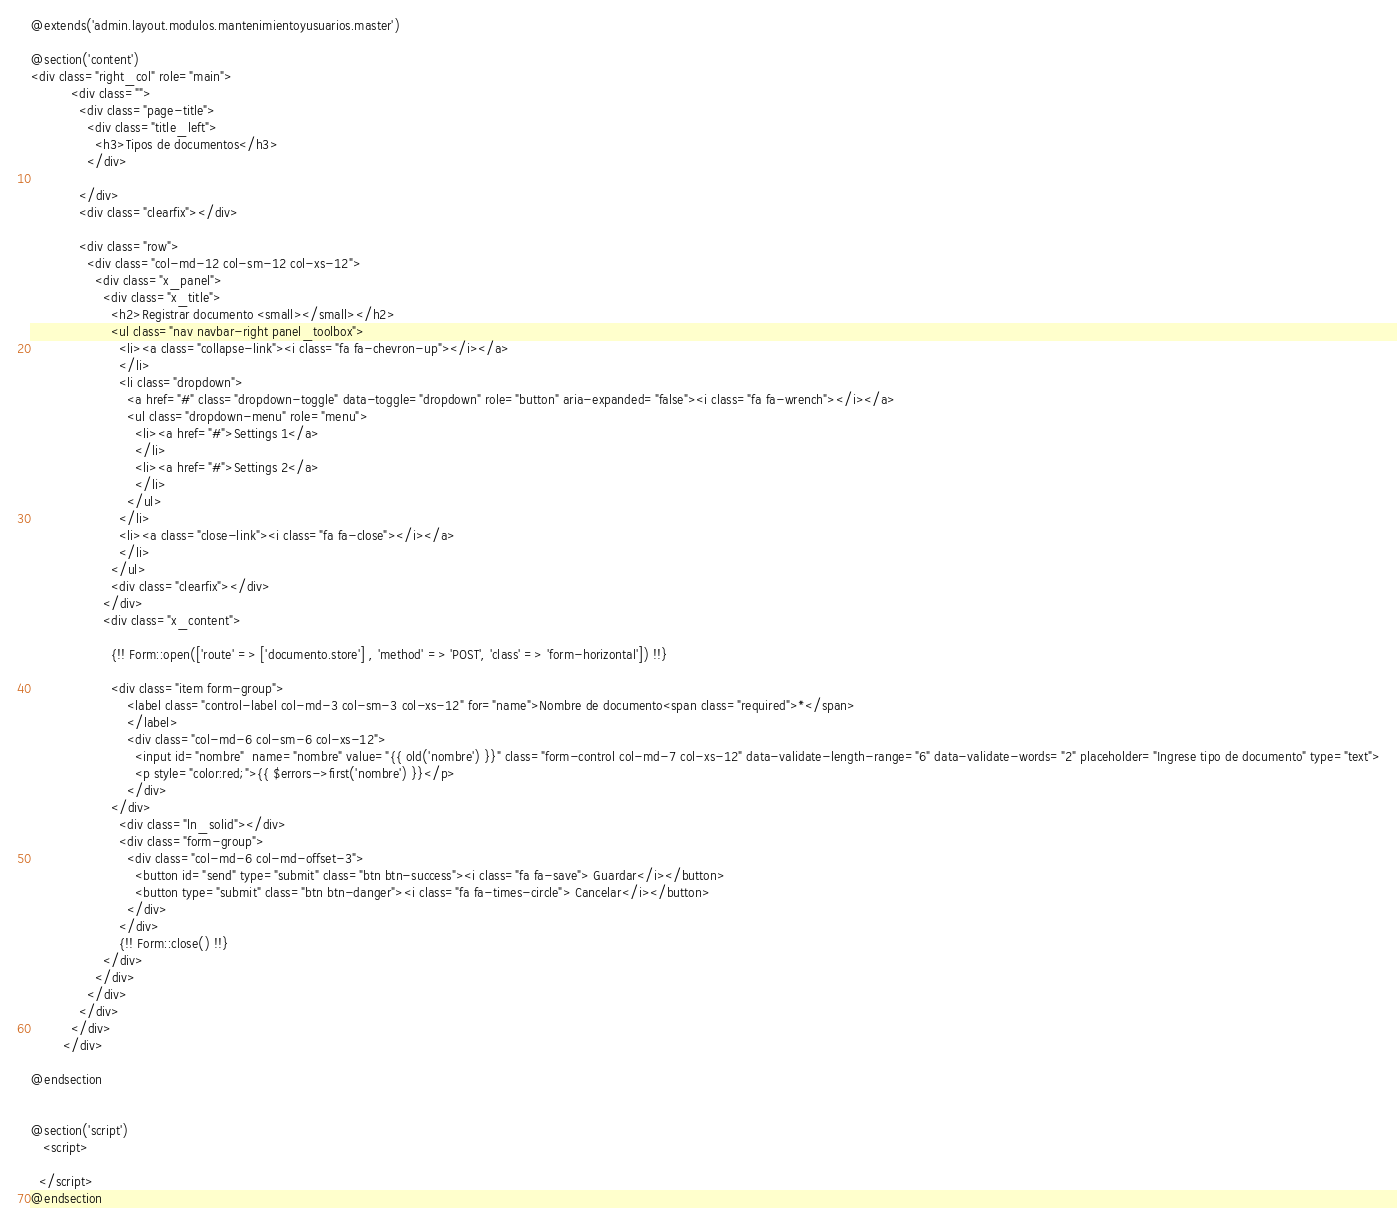<code> <loc_0><loc_0><loc_500><loc_500><_PHP_>@extends('admin.layout.modulos.mantenimientoyusuarios.master')

@section('content')
<div class="right_col" role="main">
          <div class="">
            <div class="page-title">
              <div class="title_left">
                <h3>Tipos de documentos</h3>
              </div>

            </div>
            <div class="clearfix"></div>

            <div class="row">
              <div class="col-md-12 col-sm-12 col-xs-12">
                <div class="x_panel">
                  <div class="x_title">
                    <h2>Registrar documento <small></small></h2>
                    <ul class="nav navbar-right panel_toolbox">
                      <li><a class="collapse-link"><i class="fa fa-chevron-up"></i></a>
                      </li>
                      <li class="dropdown">
                        <a href="#" class="dropdown-toggle" data-toggle="dropdown" role="button" aria-expanded="false"><i class="fa fa-wrench"></i></a>
                        <ul class="dropdown-menu" role="menu">
                          <li><a href="#">Settings 1</a>
                          </li>
                          <li><a href="#">Settings 2</a>
                          </li>
                        </ul>
                      </li>
                      <li><a class="close-link"><i class="fa fa-close"></i></a>
                      </li>
                    </ul>
                    <div class="clearfix"></div>
                  </div>
                  <div class="x_content">

                    {!! Form::open(['route' => ['documento.store'] , 'method' => 'POST', 'class' => 'form-horizontal']) !!}
                   
                    <div class="item form-group">
                        <label class="control-label col-md-3 col-sm-3 col-xs-12" for="name">Nombre de documento<span class="required">*</span>
                        </label>
                        <div class="col-md-6 col-sm-6 col-xs-12">
                          <input id="nombre"  name="nombre" value="{{ old('nombre') }}" class="form-control col-md-7 col-xs-12" data-validate-length-range="6" data-validate-words="2" placeholder="Ingrese tipo de documento" type="text">
                          <p style="color:red;">{{ $errors->first('nombre') }}</p>
                        </div>
                    </div>
                      <div class="ln_solid"></div>
                      <div class="form-group">
                        <div class="col-md-6 col-md-offset-3">
                          <button id="send" type="submit" class="btn btn-success"><i class="fa fa-save"> Guardar</i></button>
                          <button type="submit" class="btn btn-danger"><i class="fa fa-times-circle"> Cancelar</i></button>
                        </div>
                      </div>
                      {!! Form::close() !!}
                  </div>
                </div>
              </div>
            </div>
          </div>
        </div>

@endsection


@section('script')
   <script>
    
  </script>
@endsection</code> 